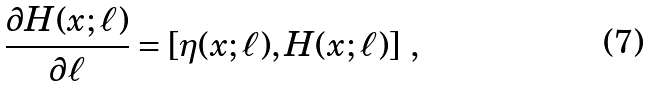Convert formula to latex. <formula><loc_0><loc_0><loc_500><loc_500>\frac { \partial H ( x ; \ell ) } { \partial \ell } = [ \eta ( x ; \ell ) , H ( x ; \ell ) ] \ ,</formula> 